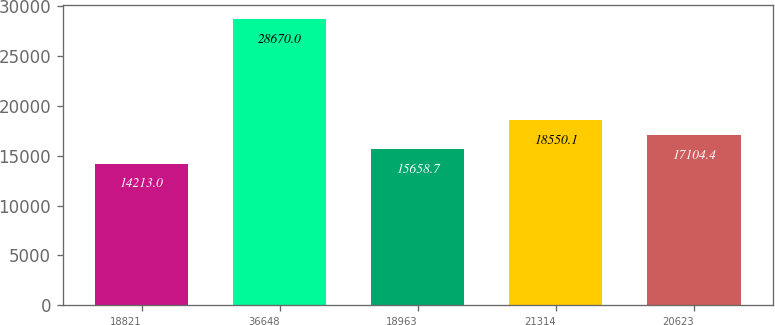<chart> <loc_0><loc_0><loc_500><loc_500><bar_chart><fcel>18821<fcel>36648<fcel>18963<fcel>21314<fcel>20623<nl><fcel>14213<fcel>28670<fcel>15658.7<fcel>18550.1<fcel>17104.4<nl></chart> 